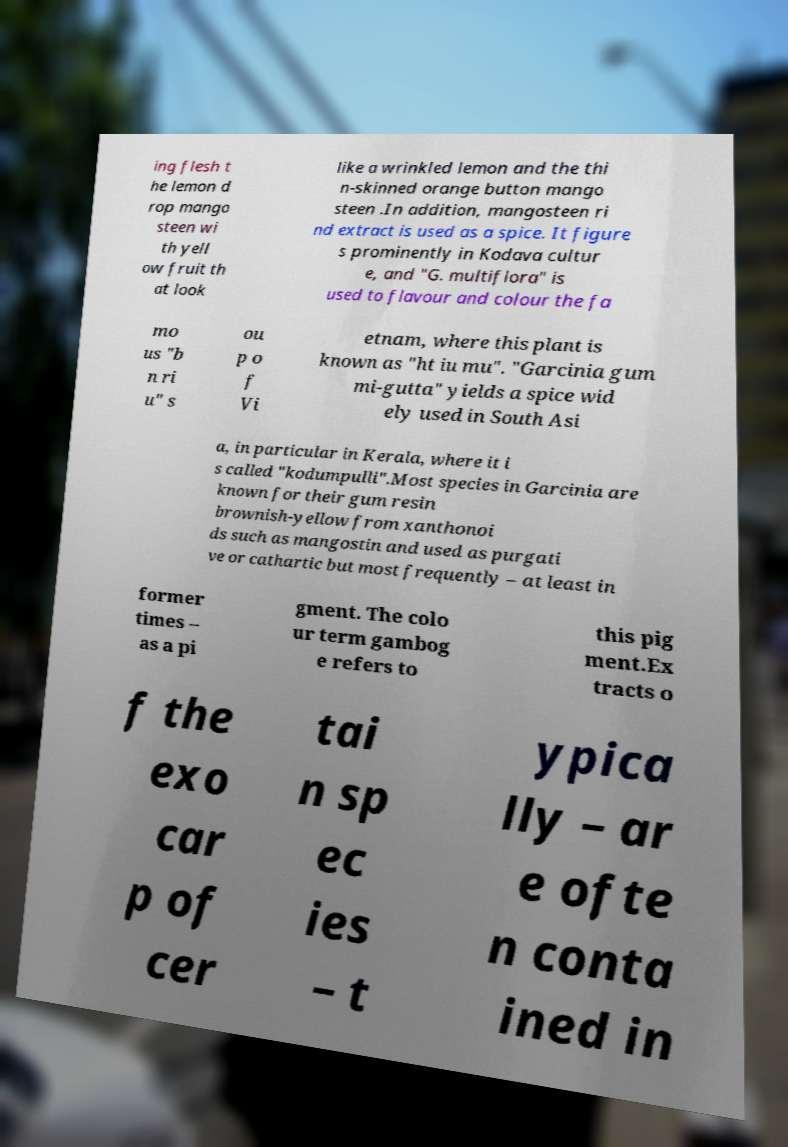Please identify and transcribe the text found in this image. ing flesh t he lemon d rop mango steen wi th yell ow fruit th at look like a wrinkled lemon and the thi n-skinned orange button mango steen .In addition, mangosteen ri nd extract is used as a spice. It figure s prominently in Kodava cultur e, and "G. multiflora" is used to flavour and colour the fa mo us "b n ri u" s ou p o f Vi etnam, where this plant is known as "ht iu mu". "Garcinia gum mi-gutta" yields a spice wid ely used in South Asi a, in particular in Kerala, where it i s called "kodumpulli".Most species in Garcinia are known for their gum resin brownish-yellow from xanthonoi ds such as mangostin and used as purgati ve or cathartic but most frequently – at least in former times – as a pi gment. The colo ur term gambog e refers to this pig ment.Ex tracts o f the exo car p of cer tai n sp ec ies – t ypica lly – ar e ofte n conta ined in 